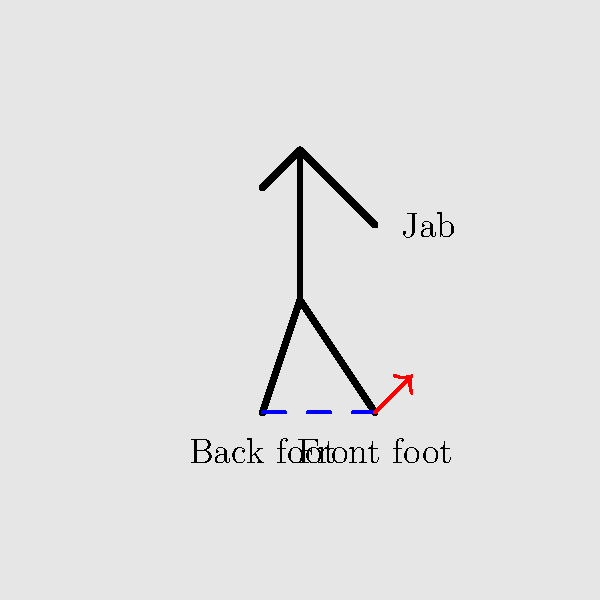In the diagram above, which element is crucial for generating power in a boxing jab, and how should it be positioned in relation to the other foot? To understand the proper stance and footwork for a boxing jab, let's break down the key elements:

1. Stance width: The feet should be positioned approximately shoulder-width apart, as shown by the dashed blue line in the diagram.

2. Weight distribution: The boxer's weight should be evenly distributed between both feet, with a slight bias towards the back foot.

3. Front foot position: The front foot (right foot in this diagram) is positioned slightly forward and is crucial for generating power in the jab.

4. Back foot position: The back foot (left foot in this diagram) provides stability and helps to generate rotational force.

5. Front foot movement: During the jab, the front foot should push off slightly, as indicated by the red arrow in the diagram. This movement helps to extend the punch and generate more power.

6. Body alignment: The body should be turned slightly sideways, with the shoulder of the jabbing arm (right shoulder in this case) slightly forward.

The front foot is crucial for generating power in a boxing jab because it serves as the pivot point and helps to transfer energy from the ground up through the body and into the punch. It should be positioned forward in relation to the back foot, allowing for a slight forward step during the jab execution.
Answer: Front foot, positioned forward 